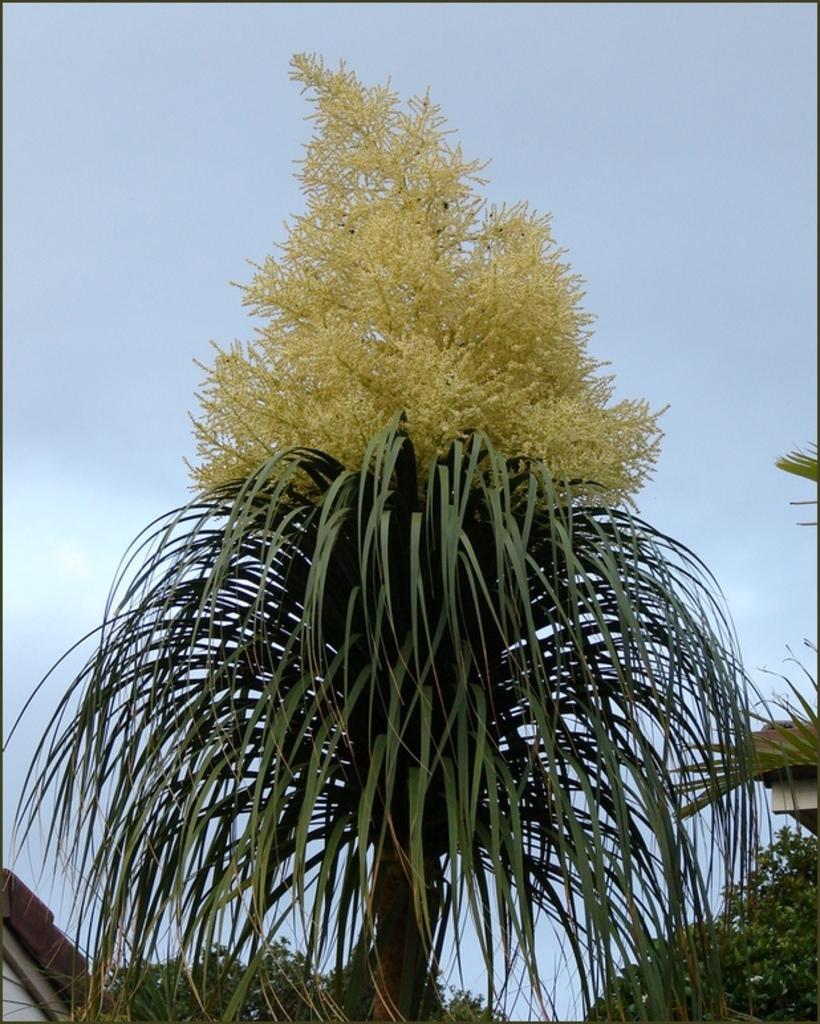Please provide a concise description of this image. In the foreground of this image, there are trees and it seems like roof in the left bottom corner. At the top, there is the sky. 